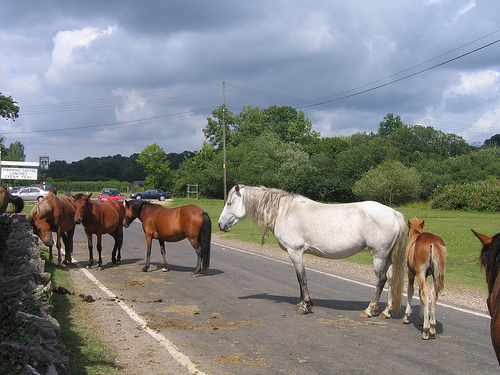<image>
Can you confirm if the car is to the left of the horse? No. The car is not to the left of the horse. From this viewpoint, they have a different horizontal relationship. 